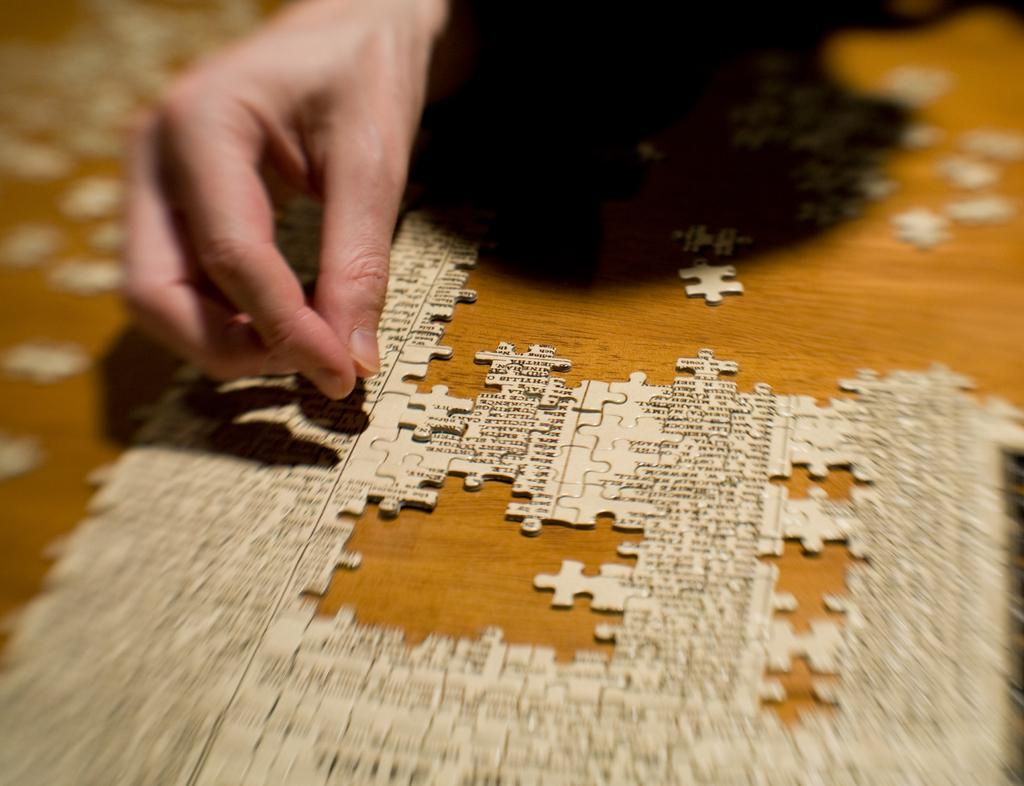What is the main object in the image? There is a puzzle in the image. Where are some pieces of the puzzle located? Some pieces of the puzzle are on the table. Can you describe any human presence in the image? There is a human hand visible in the image. What type of balloon is being held by the stranger in the image? There is no stranger or balloon present in the image; it only features a puzzle and a human hand. 